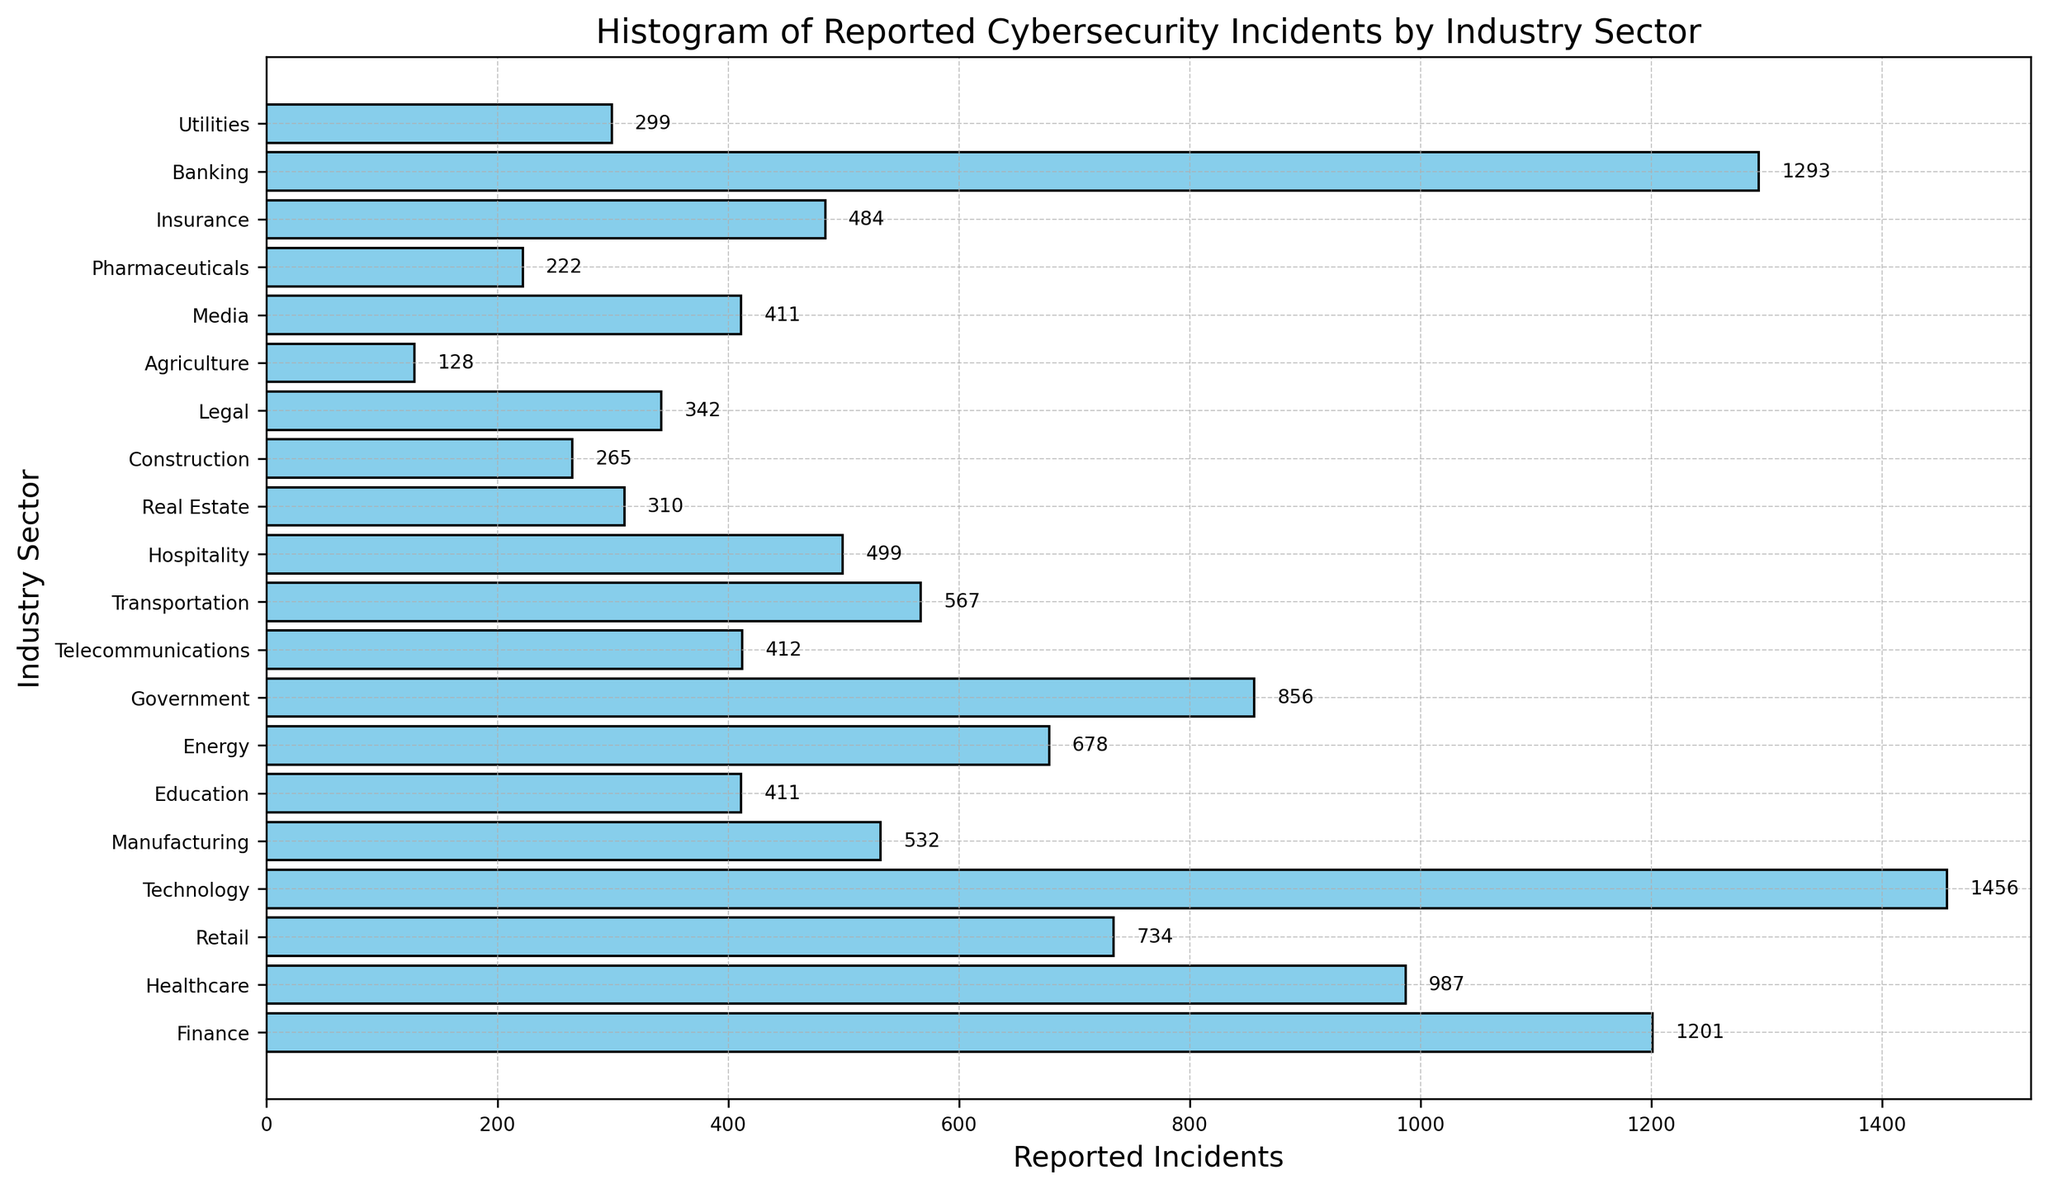What's the industry with the highest number of reported cybersecurity incidents? The bar with the greatest length represents the industry with the highest number of reported incidents. In this case, the Technology sector has the longest bar at 1456 incidents.
Answer: Technology What's the combined number of reported incidents for the Healthcare and Retail sectors? Identify the bar lengths corresponding to Healthcare and Retail sectors. Healthcare has 987 incidents and Retail has 734. Add these two values: 987 + 734 = 1721.
Answer: 1721 Which industry has reported fewer incidents, Banking or Telecommunications? Compare the lengths of the bars representing Banking (1293) and Telecommunications (412). The bar for Telecommunications is shorter.
Answer: Telecommunications What is the difference in the number of reported incidents between the Energy and Hospitality sectors? Identify the bar lengths for Energy (678) and Hospitality (499). Subtract the smaller value from the larger one: 678 - 499 = 179.
Answer: 179 Which sector reports more incidents, Education or Media? Compare the lengths of the bars for Education (411) and Media (411). Both sectors report the same number of incidents.
Answer: Same What visual element indicates the number of reported incidents for each industry in the plot? The horizontal length of each bar in the bar chart represents the number of reported incidents for each industry. The longer the bar, the higher the number of incidents.
Answer: Bar length How many industries report fewer than 400 incidents? Count the number of bars with lengths representing fewer than 400 incidents. Agriculture (128), Pharmaceuticals (222), Construction (265), Real Estate (310), Legal (342), and Utilities (299) all fall in this category.
Answer: 6 Which industry has the shortest bar in the histogram? The Agriculture sector has the shortest bar, indicating the fewest reported incidents at 128.
Answer: Agriculture How many industries report more incidents than the Insurance sector? Identify the bar length for Insurance (484) and count how many bars are longer than this. There are 10 such industries.
Answer: 10 What is the average number of reported incidents for the Finance, Technology, and Banking sectors? Add the number of incidents for each industry: Finance (1201), Technology (1456), and Banking (1293). Then divide by 3 to find the average: (1201 + 1456 + 1293) / 3 = 3950 / 3 ≈ 1316.67.
Answer: ~1316.67 